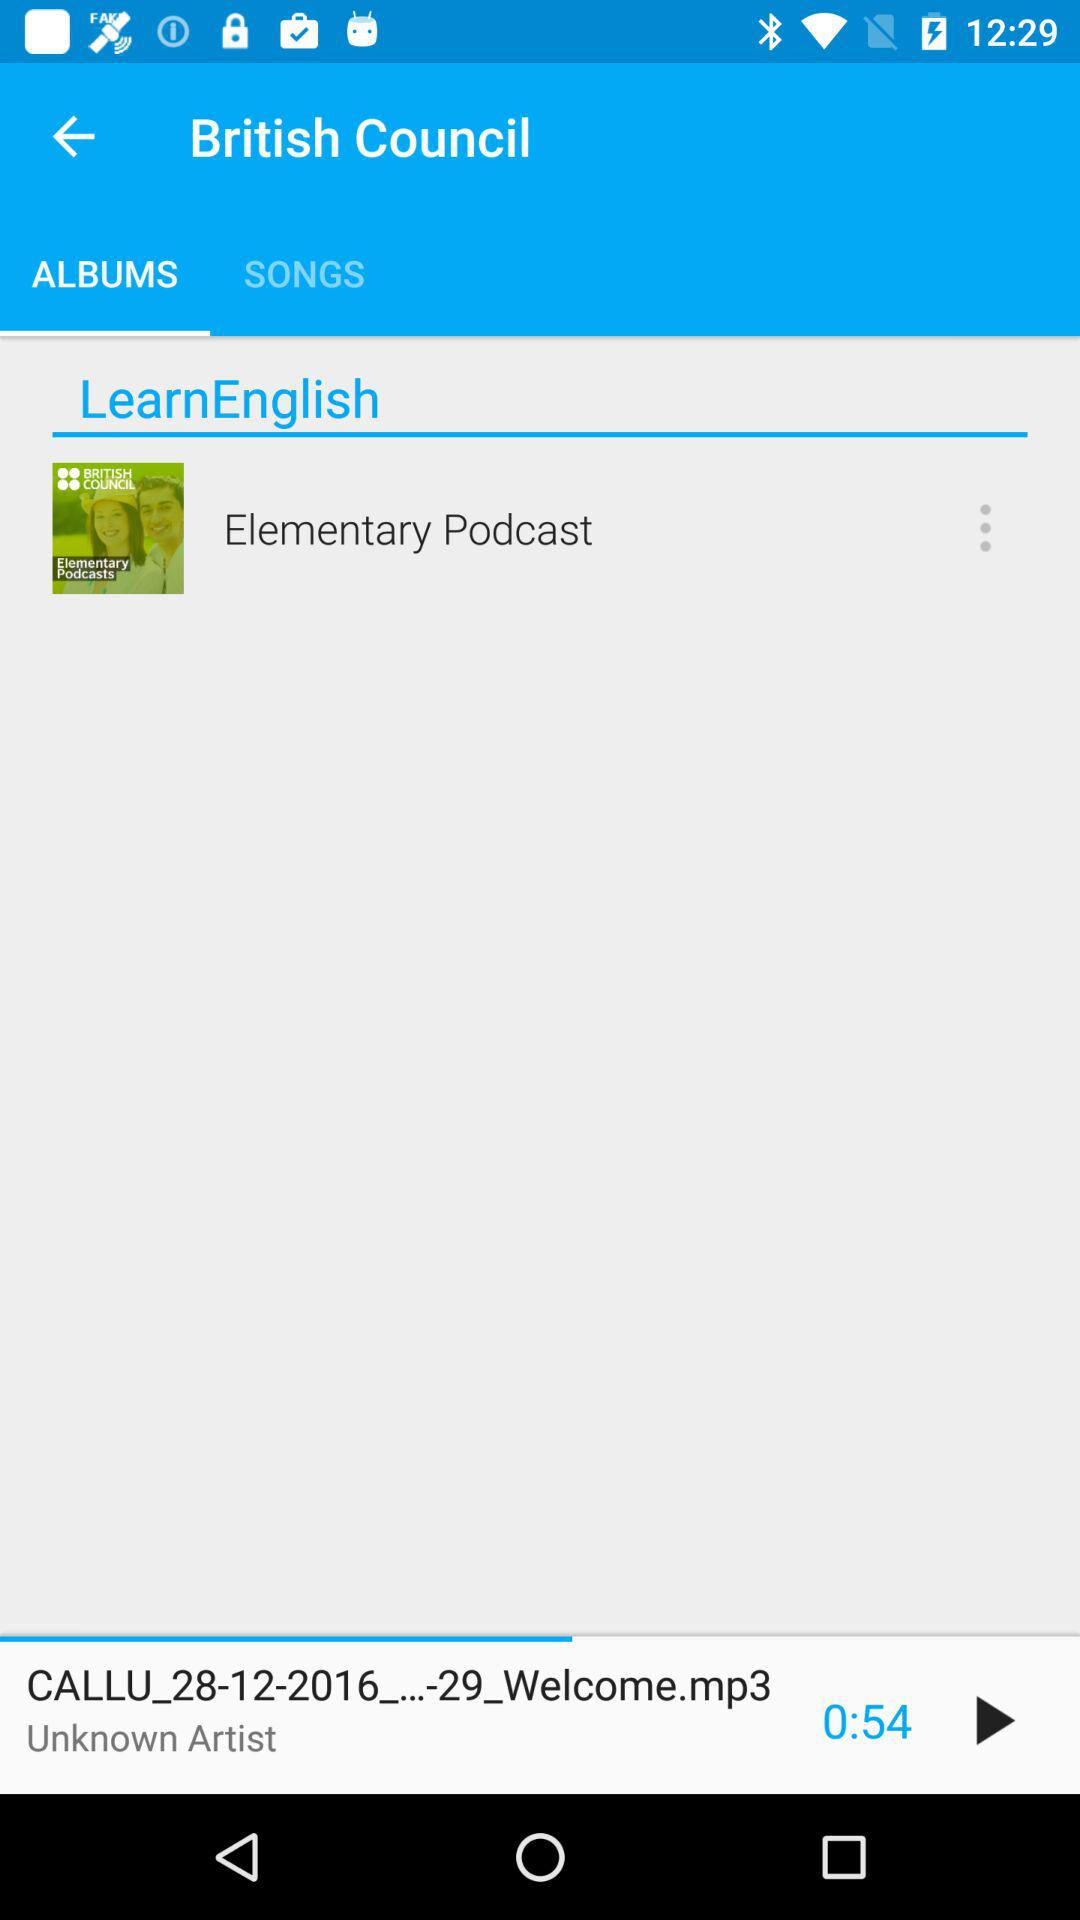Which song is playing on screen? The song that is playing on the screen is "CALLU_28-12-2016_...-29_Welcome.mp3". 